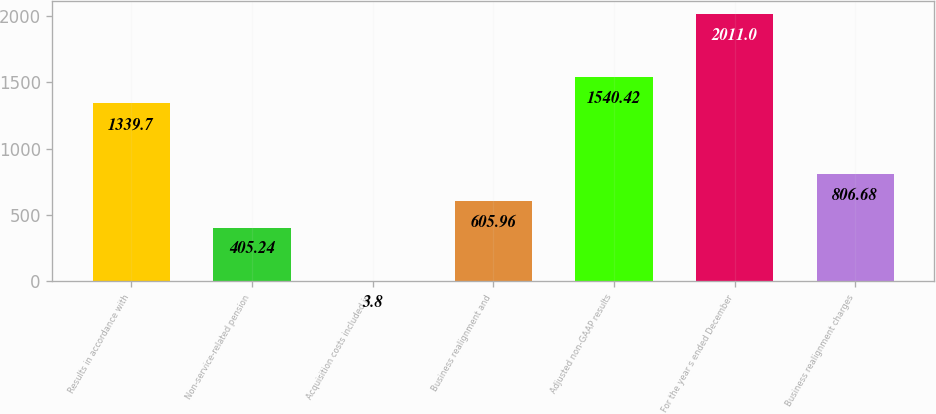<chart> <loc_0><loc_0><loc_500><loc_500><bar_chart><fcel>Results in accordance with<fcel>Non-service-related pension<fcel>Acquisition costs included in<fcel>Business realignment and<fcel>Adjusted non-GAAP results<fcel>For the year s ended December<fcel>Business realignment charges<nl><fcel>1339.7<fcel>405.24<fcel>3.8<fcel>605.96<fcel>1540.42<fcel>2011<fcel>806.68<nl></chart> 